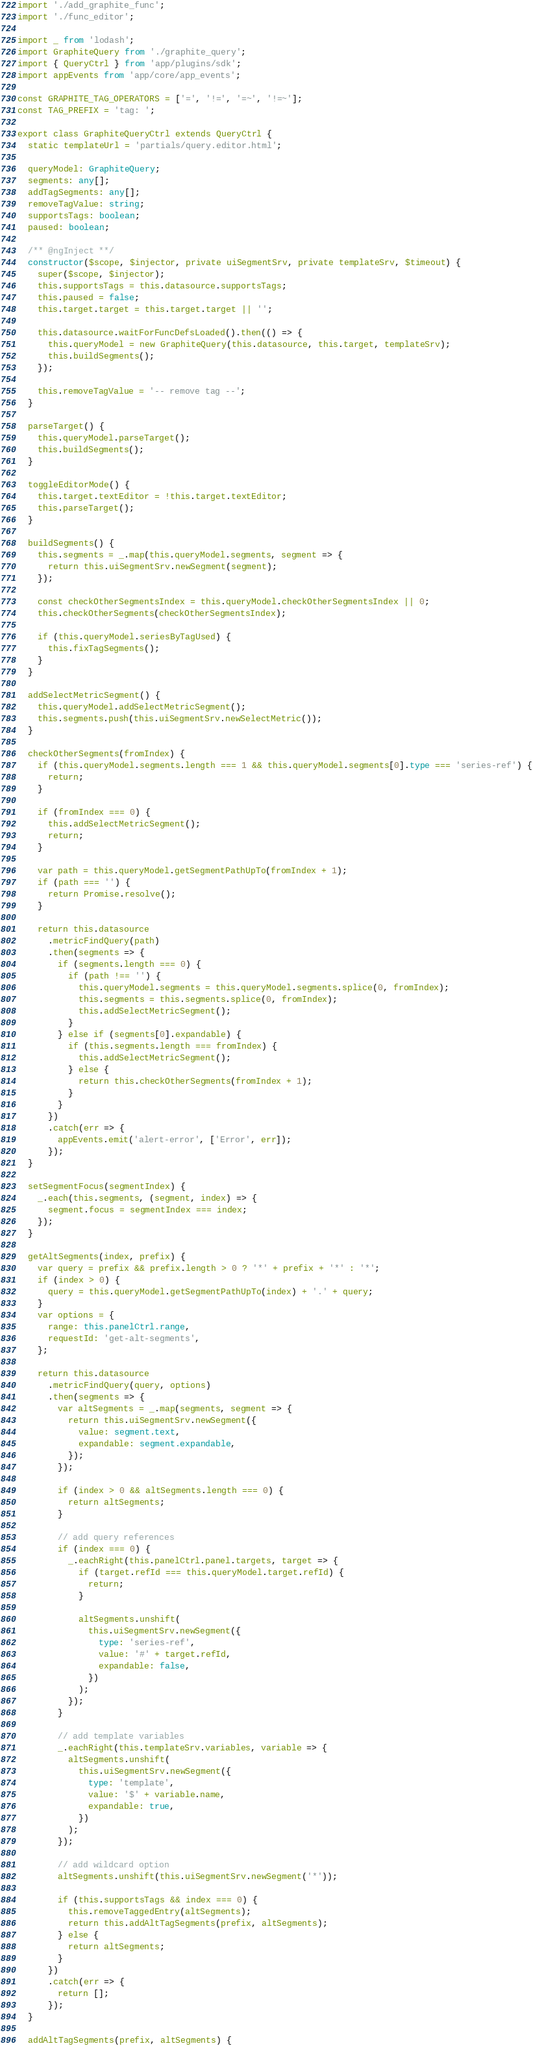<code> <loc_0><loc_0><loc_500><loc_500><_TypeScript_>import './add_graphite_func';
import './func_editor';

import _ from 'lodash';
import GraphiteQuery from './graphite_query';
import { QueryCtrl } from 'app/plugins/sdk';
import appEvents from 'app/core/app_events';

const GRAPHITE_TAG_OPERATORS = ['=', '!=', '=~', '!=~'];
const TAG_PREFIX = 'tag: ';

export class GraphiteQueryCtrl extends QueryCtrl {
  static templateUrl = 'partials/query.editor.html';

  queryModel: GraphiteQuery;
  segments: any[];
  addTagSegments: any[];
  removeTagValue: string;
  supportsTags: boolean;
  paused: boolean;

  /** @ngInject **/
  constructor($scope, $injector, private uiSegmentSrv, private templateSrv, $timeout) {
    super($scope, $injector);
    this.supportsTags = this.datasource.supportsTags;
    this.paused = false;
    this.target.target = this.target.target || '';

    this.datasource.waitForFuncDefsLoaded().then(() => {
      this.queryModel = new GraphiteQuery(this.datasource, this.target, templateSrv);
      this.buildSegments();
    });

    this.removeTagValue = '-- remove tag --';
  }

  parseTarget() {
    this.queryModel.parseTarget();
    this.buildSegments();
  }

  toggleEditorMode() {
    this.target.textEditor = !this.target.textEditor;
    this.parseTarget();
  }

  buildSegments() {
    this.segments = _.map(this.queryModel.segments, segment => {
      return this.uiSegmentSrv.newSegment(segment);
    });

    const checkOtherSegmentsIndex = this.queryModel.checkOtherSegmentsIndex || 0;
    this.checkOtherSegments(checkOtherSegmentsIndex);

    if (this.queryModel.seriesByTagUsed) {
      this.fixTagSegments();
    }
  }

  addSelectMetricSegment() {
    this.queryModel.addSelectMetricSegment();
    this.segments.push(this.uiSegmentSrv.newSelectMetric());
  }

  checkOtherSegments(fromIndex) {
    if (this.queryModel.segments.length === 1 && this.queryModel.segments[0].type === 'series-ref') {
      return;
    }

    if (fromIndex === 0) {
      this.addSelectMetricSegment();
      return;
    }

    var path = this.queryModel.getSegmentPathUpTo(fromIndex + 1);
    if (path === '') {
      return Promise.resolve();
    }

    return this.datasource
      .metricFindQuery(path)
      .then(segments => {
        if (segments.length === 0) {
          if (path !== '') {
            this.queryModel.segments = this.queryModel.segments.splice(0, fromIndex);
            this.segments = this.segments.splice(0, fromIndex);
            this.addSelectMetricSegment();
          }
        } else if (segments[0].expandable) {
          if (this.segments.length === fromIndex) {
            this.addSelectMetricSegment();
          } else {
            return this.checkOtherSegments(fromIndex + 1);
          }
        }
      })
      .catch(err => {
        appEvents.emit('alert-error', ['Error', err]);
      });
  }

  setSegmentFocus(segmentIndex) {
    _.each(this.segments, (segment, index) => {
      segment.focus = segmentIndex === index;
    });
  }

  getAltSegments(index, prefix) {
    var query = prefix && prefix.length > 0 ? '*' + prefix + '*' : '*';
    if (index > 0) {
      query = this.queryModel.getSegmentPathUpTo(index) + '.' + query;
    }
    var options = {
      range: this.panelCtrl.range,
      requestId: 'get-alt-segments',
    };

    return this.datasource
      .metricFindQuery(query, options)
      .then(segments => {
        var altSegments = _.map(segments, segment => {
          return this.uiSegmentSrv.newSegment({
            value: segment.text,
            expandable: segment.expandable,
          });
        });

        if (index > 0 && altSegments.length === 0) {
          return altSegments;
        }

        // add query references
        if (index === 0) {
          _.eachRight(this.panelCtrl.panel.targets, target => {
            if (target.refId === this.queryModel.target.refId) {
              return;
            }

            altSegments.unshift(
              this.uiSegmentSrv.newSegment({
                type: 'series-ref',
                value: '#' + target.refId,
                expandable: false,
              })
            );
          });
        }

        // add template variables
        _.eachRight(this.templateSrv.variables, variable => {
          altSegments.unshift(
            this.uiSegmentSrv.newSegment({
              type: 'template',
              value: '$' + variable.name,
              expandable: true,
            })
          );
        });

        // add wildcard option
        altSegments.unshift(this.uiSegmentSrv.newSegment('*'));

        if (this.supportsTags && index === 0) {
          this.removeTaggedEntry(altSegments);
          return this.addAltTagSegments(prefix, altSegments);
        } else {
          return altSegments;
        }
      })
      .catch(err => {
        return [];
      });
  }

  addAltTagSegments(prefix, altSegments) {</code> 